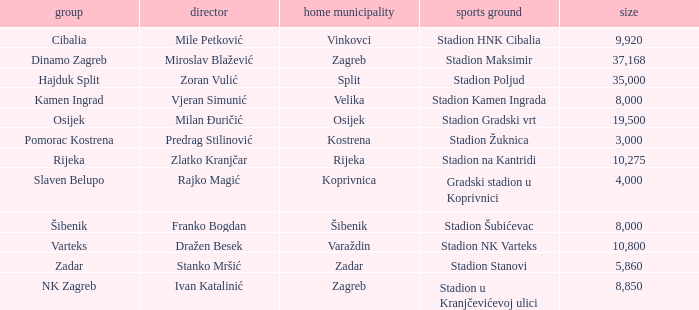What team that has a Home city of Zadar? Zadar. 